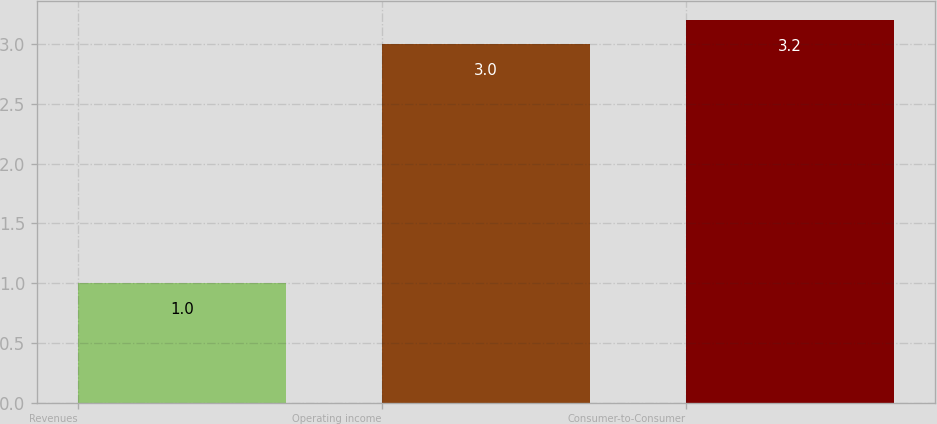<chart> <loc_0><loc_0><loc_500><loc_500><bar_chart><fcel>Revenues<fcel>Operating income<fcel>Consumer-to-Consumer<nl><fcel>1<fcel>3<fcel>3.2<nl></chart> 